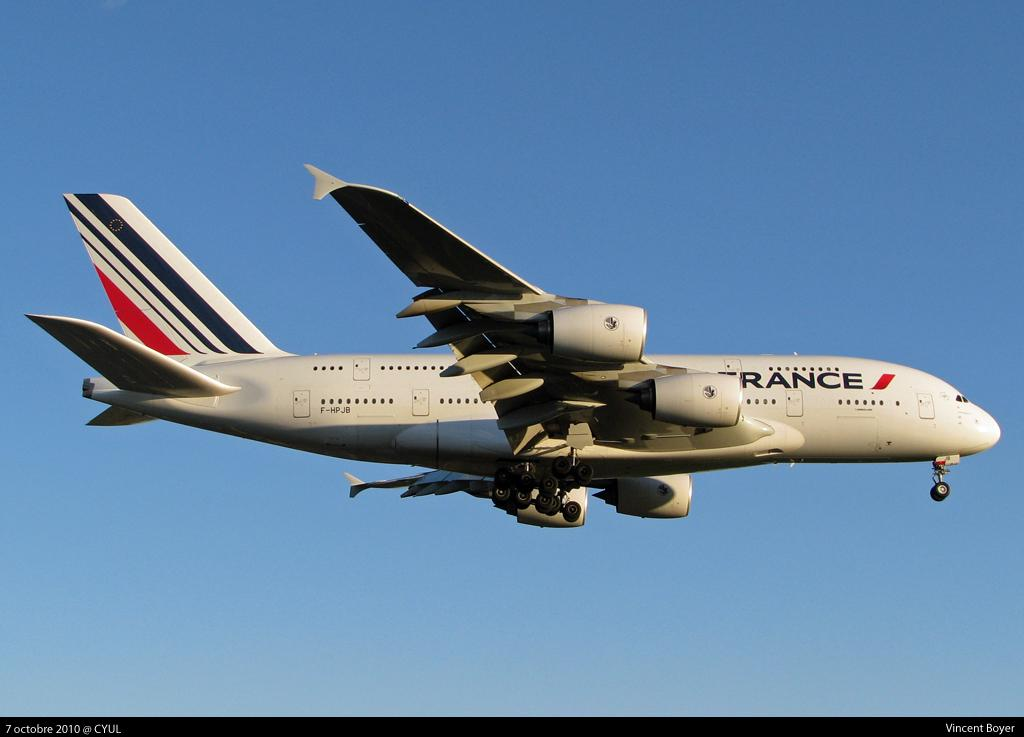<image>
Describe the image concisely. An Air France Jumbo jet in clear blue sky, taken from the ground 